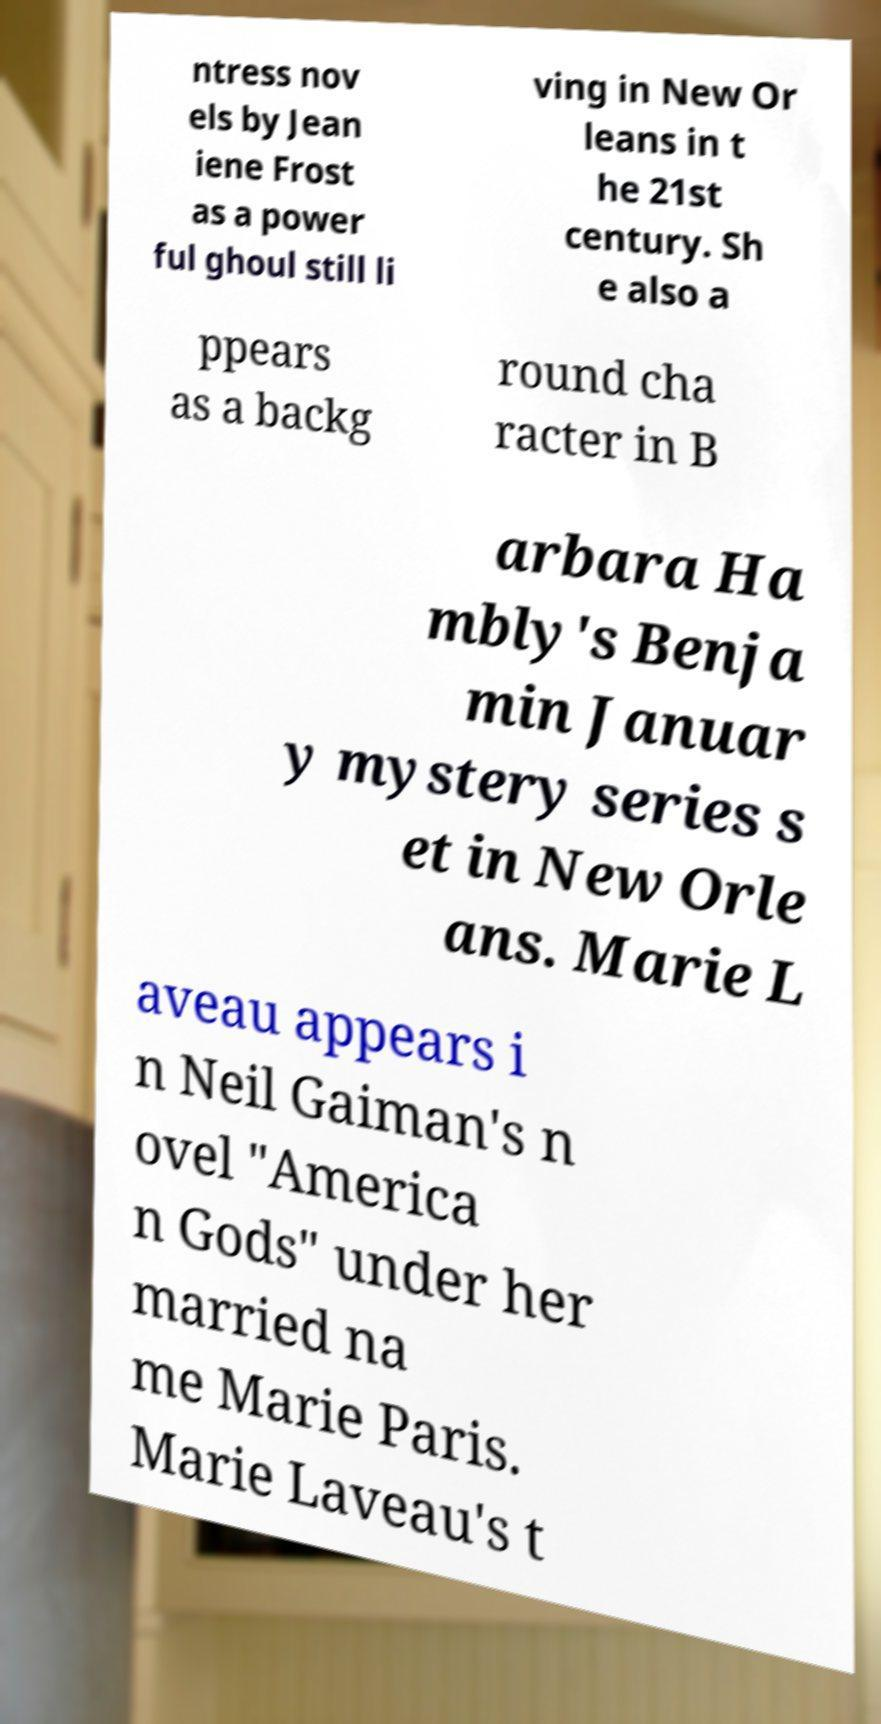For documentation purposes, I need the text within this image transcribed. Could you provide that? ntress nov els by Jean iene Frost as a power ful ghoul still li ving in New Or leans in t he 21st century. Sh e also a ppears as a backg round cha racter in B arbara Ha mbly's Benja min Januar y mystery series s et in New Orle ans. Marie L aveau appears i n Neil Gaiman's n ovel "America n Gods" under her married na me Marie Paris. Marie Laveau's t 